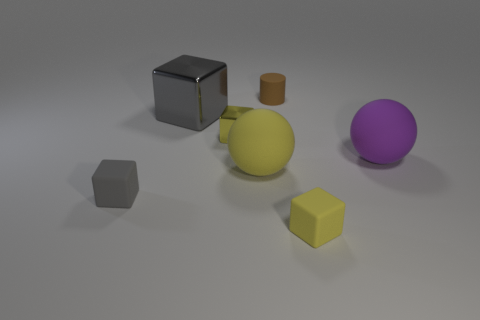Subtract all large gray metal cubes. How many cubes are left? 3 Subtract all green balls. How many gray cubes are left? 2 Add 3 purple objects. How many objects exist? 10 Subtract all gray cubes. How many cubes are left? 2 Subtract all spheres. How many objects are left? 5 Add 3 gray metal things. How many gray metal things exist? 4 Subtract 0 gray balls. How many objects are left? 7 Subtract all blue cubes. Subtract all gray balls. How many cubes are left? 4 Subtract all yellow objects. Subtract all large gray metallic blocks. How many objects are left? 3 Add 7 yellow objects. How many yellow objects are left? 10 